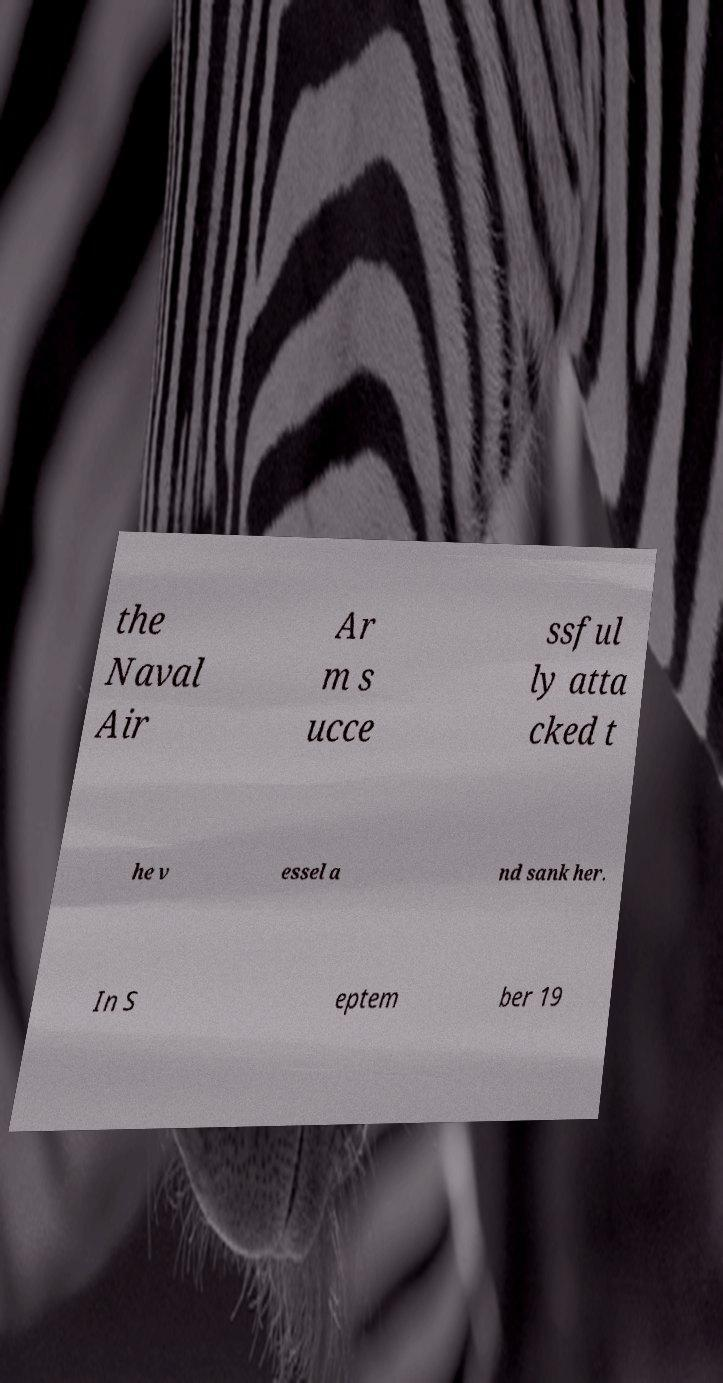Can you read and provide the text displayed in the image?This photo seems to have some interesting text. Can you extract and type it out for me? the Naval Air Ar m s ucce ssful ly atta cked t he v essel a nd sank her. In S eptem ber 19 